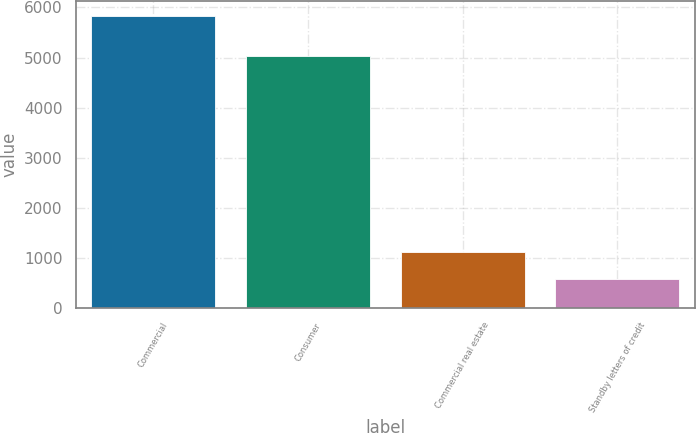Convert chart. <chart><loc_0><loc_0><loc_500><loc_500><bar_chart><fcel>Commercial<fcel>Consumer<fcel>Commercial real estate<fcel>Standby letters of credit<nl><fcel>5834<fcel>5028<fcel>1102.7<fcel>577<nl></chart> 